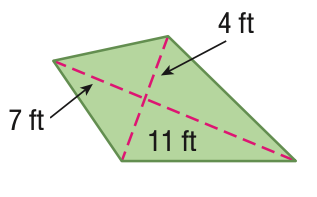Question: Find the area of the kite.
Choices:
A. 28
B. 44
C. 72
D. 144
Answer with the letter. Answer: C 